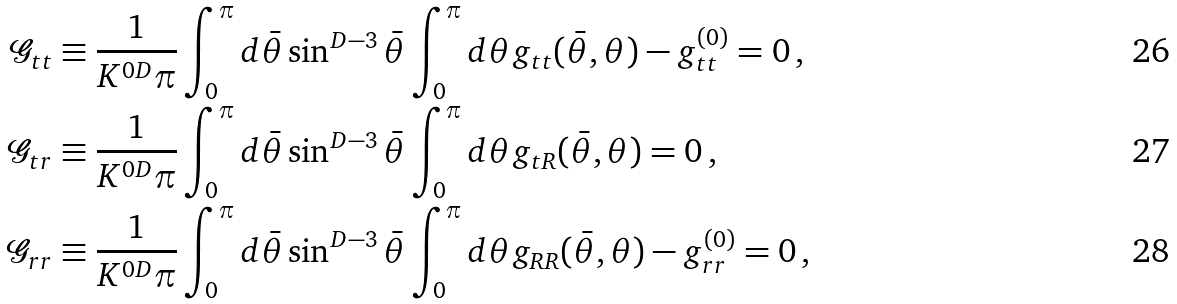Convert formula to latex. <formula><loc_0><loc_0><loc_500><loc_500>\mathcal { G } _ { t t } & \equiv \frac { 1 } { K ^ { 0 D } \pi } \int _ { 0 } ^ { \pi } d \bar { \theta } \sin ^ { D - 3 } \bar { \theta } \int _ { 0 } ^ { \pi } d \theta g _ { t t } ( \bar { \theta } , \theta ) - g _ { t t } ^ { ( 0 ) } = 0 \, , \\ \mathcal { G } _ { t r } & \equiv \frac { 1 } { K ^ { 0 D } \pi } \int _ { 0 } ^ { \pi } d \bar { \theta } \sin ^ { D - 3 } \bar { \theta } \int _ { 0 } ^ { \pi } d \theta g _ { t R } ( \bar { \theta } , \theta ) = 0 \, , \\ \mathcal { G } _ { r r } & \equiv \frac { 1 } { K ^ { 0 D } \pi } \int _ { 0 } ^ { \pi } d \bar { \theta } \sin ^ { D - 3 } \bar { \theta } \int _ { 0 } ^ { \pi } d \theta g _ { R R } ( \bar { \theta } , \theta ) - g _ { r r } ^ { ( 0 ) } = 0 \, ,</formula> 